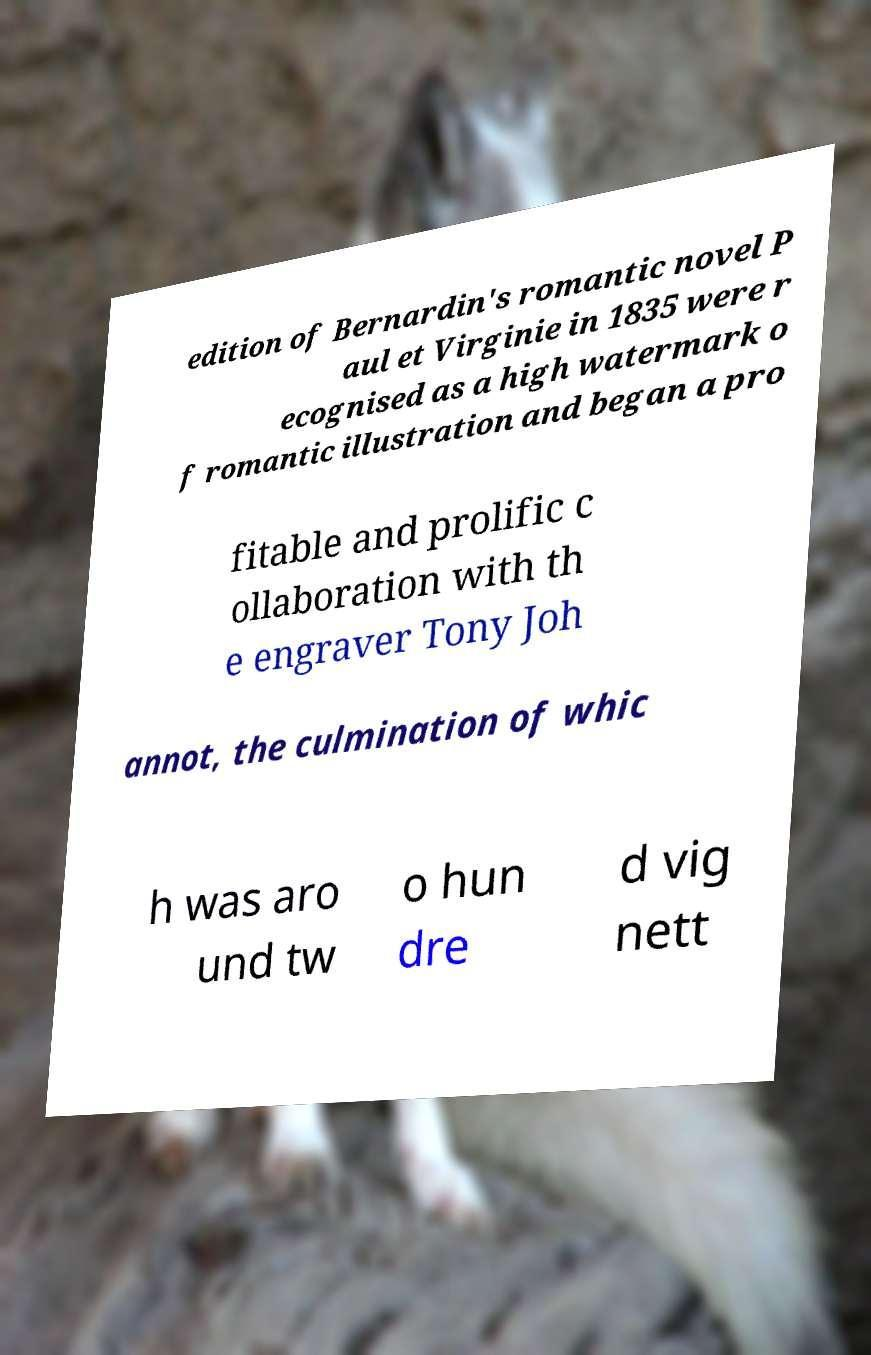There's text embedded in this image that I need extracted. Can you transcribe it verbatim? edition of Bernardin's romantic novel P aul et Virginie in 1835 were r ecognised as a high watermark o f romantic illustration and began a pro fitable and prolific c ollaboration with th e engraver Tony Joh annot, the culmination of whic h was aro und tw o hun dre d vig nett 